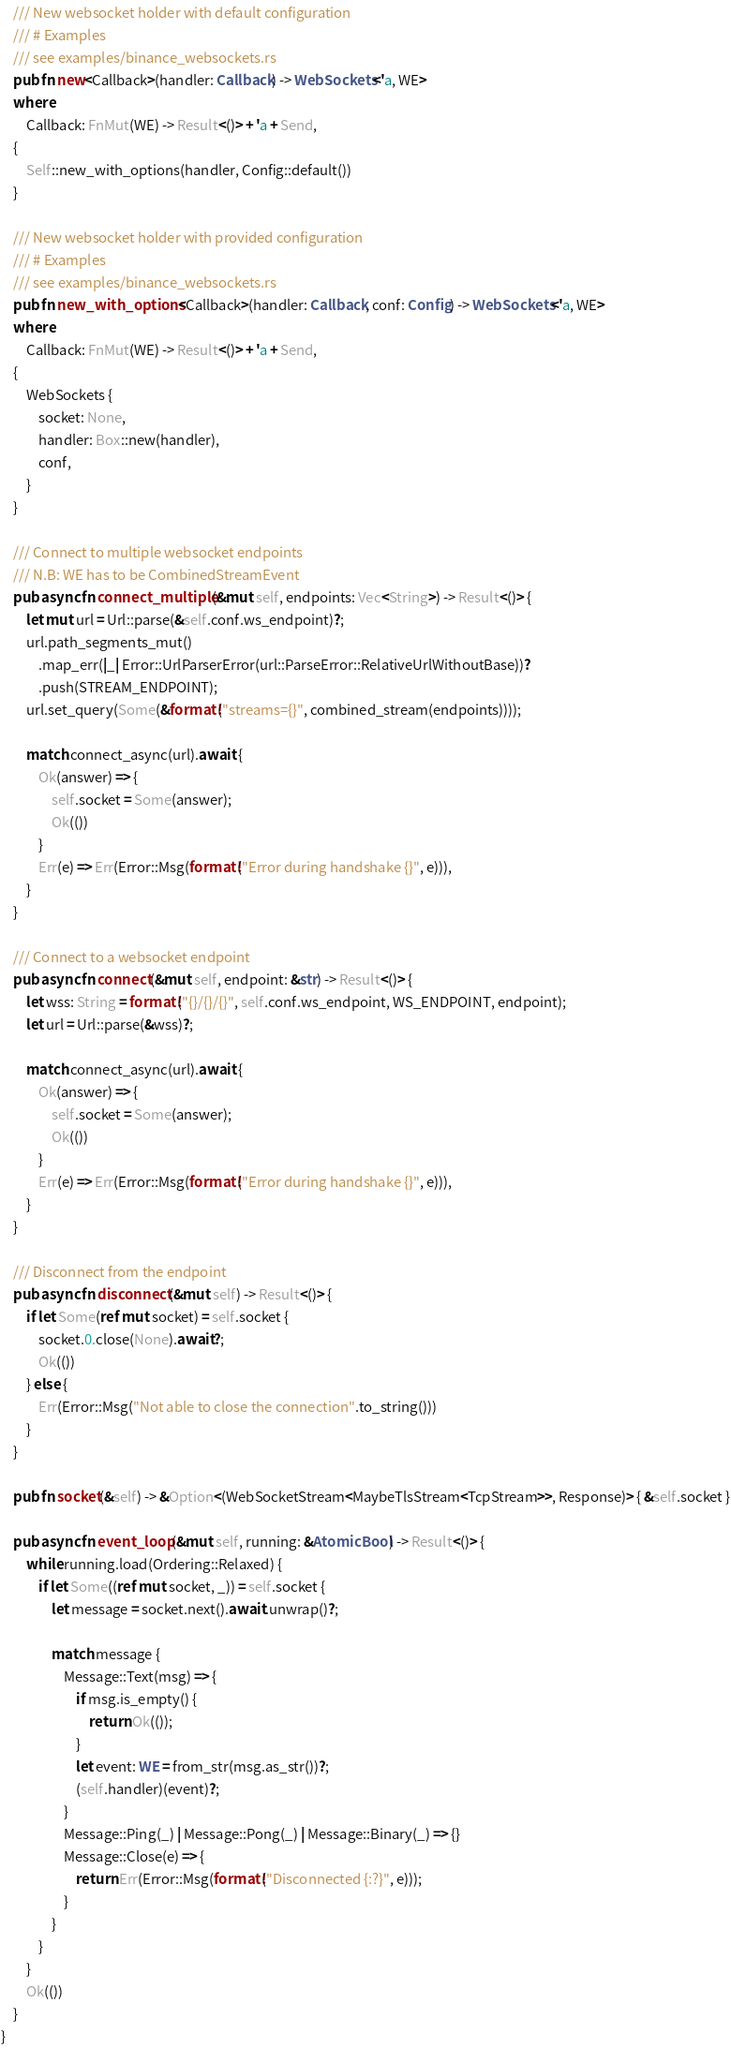<code> <loc_0><loc_0><loc_500><loc_500><_Rust_>    /// New websocket holder with default configuration
    /// # Examples
    /// see examples/binance_websockets.rs
    pub fn new<Callback>(handler: Callback) -> WebSockets<'a, WE>
    where
        Callback: FnMut(WE) -> Result<()> + 'a + Send,
    {
        Self::new_with_options(handler, Config::default())
    }

    /// New websocket holder with provided configuration
    /// # Examples
    /// see examples/binance_websockets.rs
    pub fn new_with_options<Callback>(handler: Callback, conf: Config) -> WebSockets<'a, WE>
    where
        Callback: FnMut(WE) -> Result<()> + 'a + Send,
    {
        WebSockets {
            socket: None,
            handler: Box::new(handler),
            conf,
        }
    }

    /// Connect to multiple websocket endpoints
    /// N.B: WE has to be CombinedStreamEvent
    pub async fn connect_multiple(&mut self, endpoints: Vec<String>) -> Result<()> {
        let mut url = Url::parse(&self.conf.ws_endpoint)?;
        url.path_segments_mut()
            .map_err(|_| Error::UrlParserError(url::ParseError::RelativeUrlWithoutBase))?
            .push(STREAM_ENDPOINT);
        url.set_query(Some(&format!("streams={}", combined_stream(endpoints))));

        match connect_async(url).await {
            Ok(answer) => {
                self.socket = Some(answer);
                Ok(())
            }
            Err(e) => Err(Error::Msg(format!("Error during handshake {}", e))),
        }
    }

    /// Connect to a websocket endpoint
    pub async fn connect(&mut self, endpoint: &str) -> Result<()> {
        let wss: String = format!("{}/{}/{}", self.conf.ws_endpoint, WS_ENDPOINT, endpoint);
        let url = Url::parse(&wss)?;

        match connect_async(url).await {
            Ok(answer) => {
                self.socket = Some(answer);
                Ok(())
            }
            Err(e) => Err(Error::Msg(format!("Error during handshake {}", e))),
        }
    }

    /// Disconnect from the endpoint
    pub async fn disconnect(&mut self) -> Result<()> {
        if let Some(ref mut socket) = self.socket {
            socket.0.close(None).await?;
            Ok(())
        } else {
            Err(Error::Msg("Not able to close the connection".to_string()))
        }
    }

    pub fn socket(&self) -> &Option<(WebSocketStream<MaybeTlsStream<TcpStream>>, Response)> { &self.socket }

    pub async fn event_loop(&mut self, running: &AtomicBool) -> Result<()> {
        while running.load(Ordering::Relaxed) {
            if let Some((ref mut socket, _)) = self.socket {
                let message = socket.next().await.unwrap()?;

                match message {
                    Message::Text(msg) => {
                        if msg.is_empty() {
                            return Ok(());
                        }
                        let event: WE = from_str(msg.as_str())?;
                        (self.handler)(event)?;
                    }
                    Message::Ping(_) | Message::Pong(_) | Message::Binary(_) => {}
                    Message::Close(e) => {
                        return Err(Error::Msg(format!("Disconnected {:?}", e)));
                    }
                }
            }
        }
        Ok(())
    }
}
</code> 